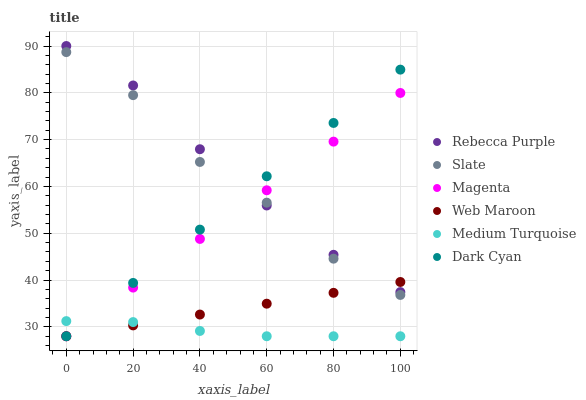Does Medium Turquoise have the minimum area under the curve?
Answer yes or no. Yes. Does Rebecca Purple have the maximum area under the curve?
Answer yes or no. Yes. Does Web Maroon have the minimum area under the curve?
Answer yes or no. No. Does Web Maroon have the maximum area under the curve?
Answer yes or no. No. Is Dark Cyan the smoothest?
Answer yes or no. Yes. Is Slate the roughest?
Answer yes or no. Yes. Is Web Maroon the smoothest?
Answer yes or no. No. Is Web Maroon the roughest?
Answer yes or no. No. Does Web Maroon have the lowest value?
Answer yes or no. Yes. Does Rebecca Purple have the lowest value?
Answer yes or no. No. Does Rebecca Purple have the highest value?
Answer yes or no. Yes. Does Web Maroon have the highest value?
Answer yes or no. No. Is Medium Turquoise less than Rebecca Purple?
Answer yes or no. Yes. Is Slate greater than Medium Turquoise?
Answer yes or no. Yes. Does Web Maroon intersect Magenta?
Answer yes or no. Yes. Is Web Maroon less than Magenta?
Answer yes or no. No. Is Web Maroon greater than Magenta?
Answer yes or no. No. Does Medium Turquoise intersect Rebecca Purple?
Answer yes or no. No. 